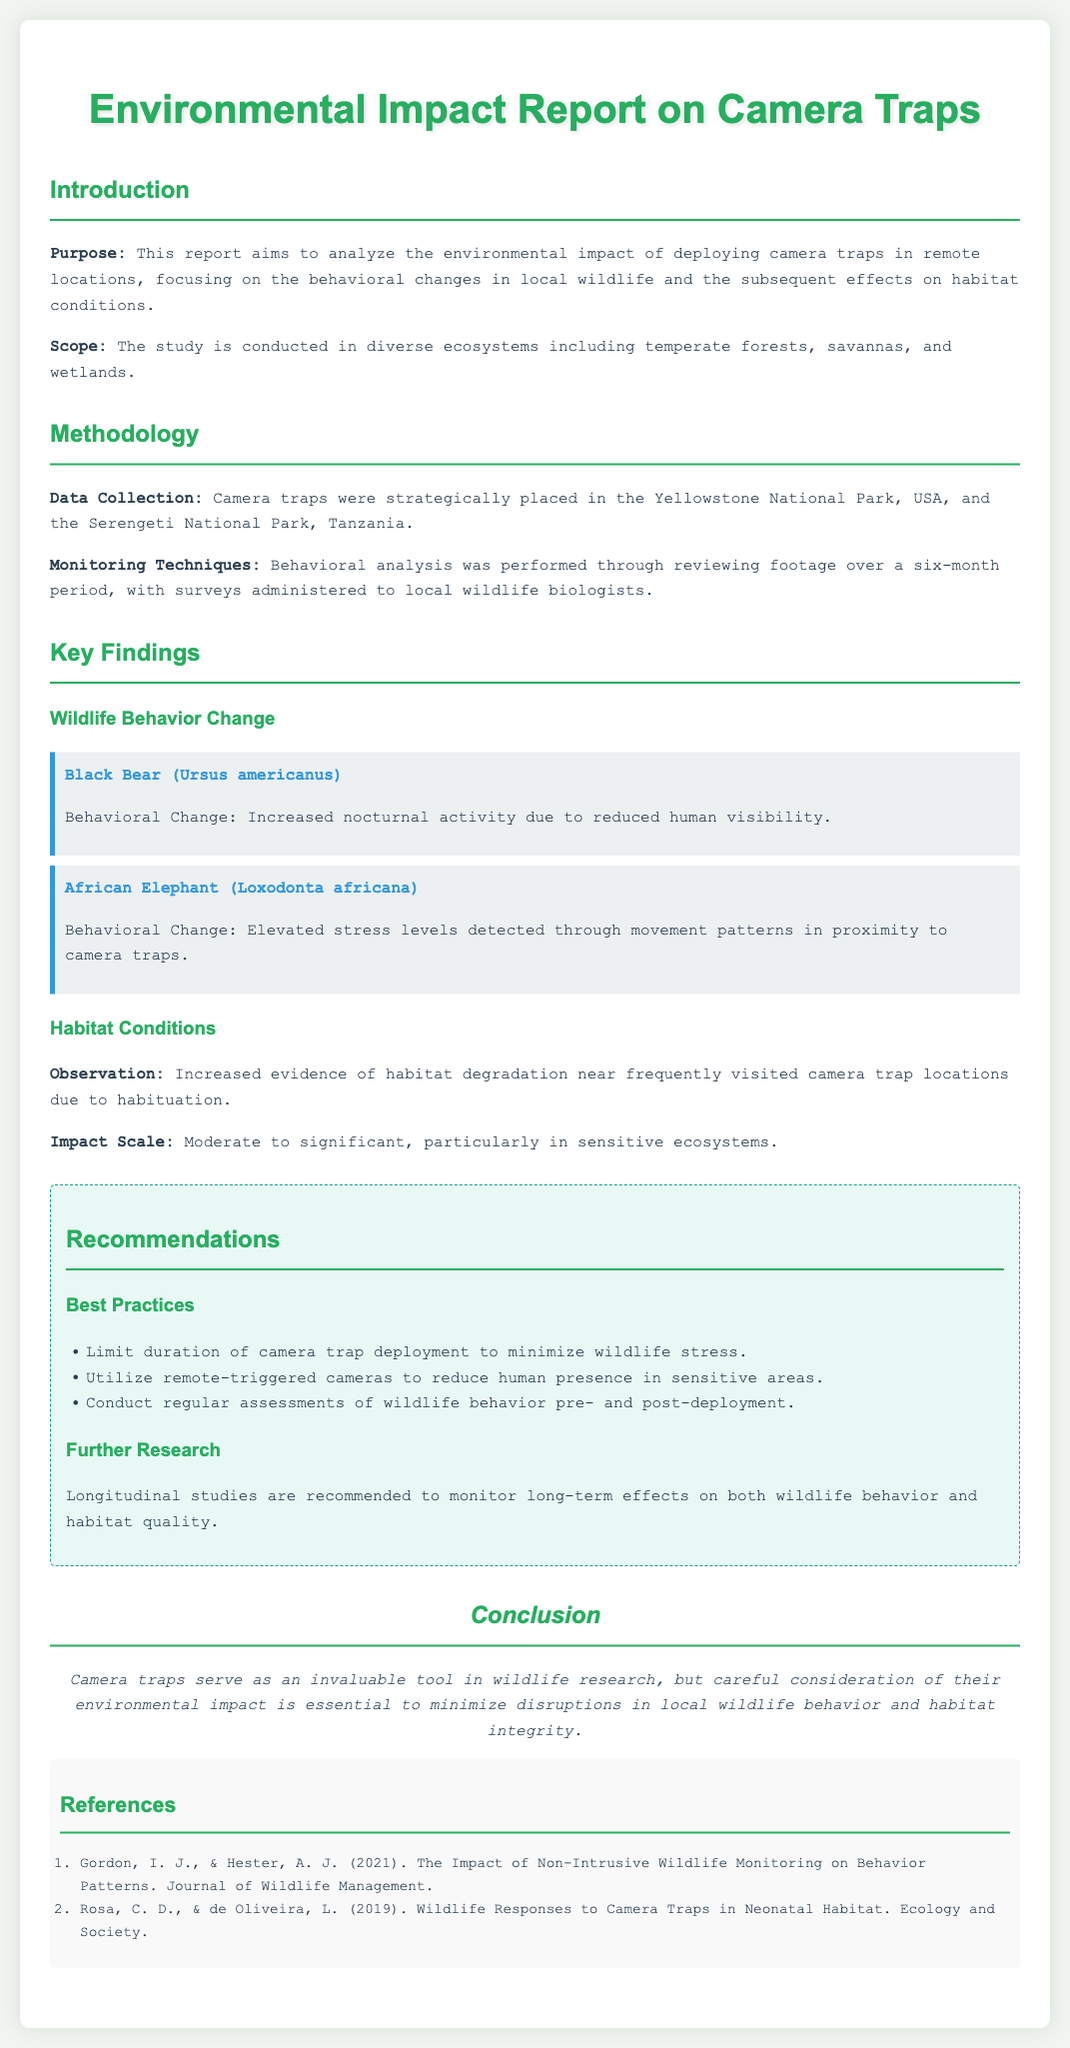What is the purpose of the report? The report aims to analyze the environmental impact of deploying camera traps in remote locations, focusing on the behavioral changes in local wildlife and the subsequent effects on habitat conditions.
Answer: Analyze environmental impact Where were the camera traps deployed? The camera traps were strategically placed in Yellowstone National Park, USA, and Serengeti National Park, Tanzania.
Answer: Yellowstone National Park, USA; Serengeti National Park, Tanzania Which wildlife species showed increased nocturnal activity? The behavior of the Black Bear is noted to have increased nocturnal activity due to reduced human visibility.
Answer: Black Bear What is a noted impact on habitat conditions? Increased evidence of habitat degradation near frequently visited camera trap locations due to habituation is observed.
Answer: Habitat degradation What type of studies are recommended for further research? Longitudinal studies are recommended to monitor long-term effects on both wildlife behavior and habitat quality.
Answer: Longitudinal studies How long was the monitoring period for the behavioral analysis? The monitoring period for behavioral analysis was over a six-month period.
Answer: Six months What is the impact scale of habitat conditions? The impact scale on habitat conditions is noted as moderate to significant, particularly in sensitive ecosystems.
Answer: Moderate to significant What do the best practices recommend regarding camera trap deployment duration? The report recommends limiting the duration of camera trap deployment to minimize wildlife stress.
Answer: Limit duration 